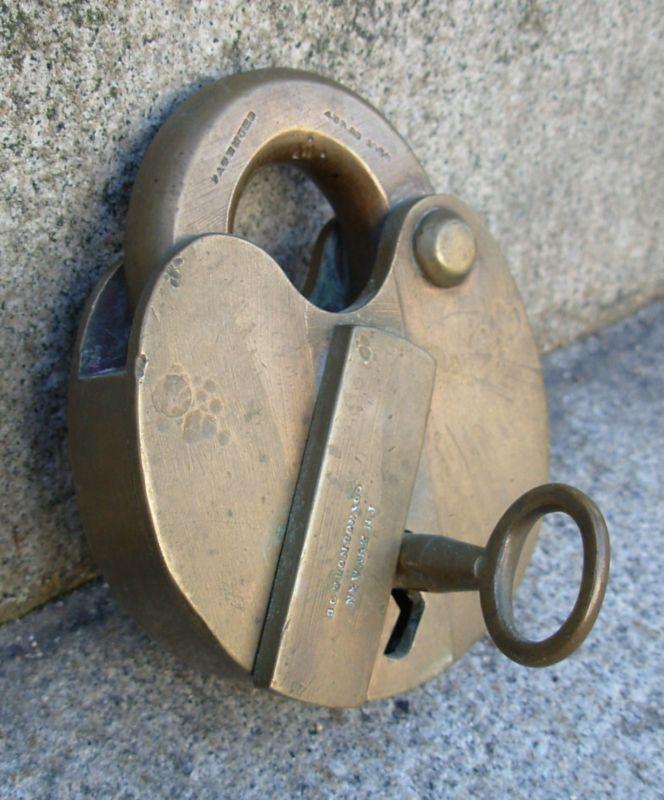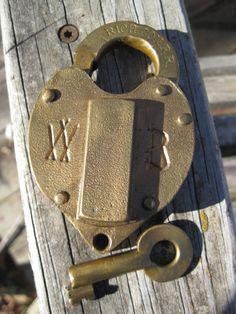The first image is the image on the left, the second image is the image on the right. For the images displayed, is the sentence "Each image contains only non-square vintage locks and contains at least one key." factually correct? Answer yes or no. Yes. The first image is the image on the left, the second image is the image on the right. Examine the images to the left and right. Is the description "At least one key is lying beside a lock." accurate? Answer yes or no. Yes. 